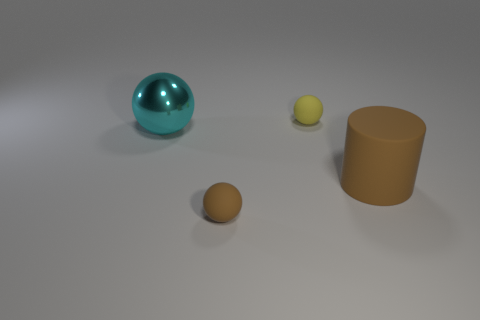Add 4 brown rubber cylinders. How many objects exist? 8 Subtract all large cyan spheres. How many spheres are left? 2 Subtract 1 cylinders. How many cylinders are left? 0 Subtract all cyan spheres. How many spheres are left? 2 Subtract all cylinders. How many objects are left? 3 Add 1 balls. How many balls are left? 4 Add 2 tiny matte things. How many tiny matte things exist? 4 Subtract 0 green balls. How many objects are left? 4 Subtract all gray cylinders. Subtract all gray spheres. How many cylinders are left? 1 Subtract all purple blocks. How many yellow spheres are left? 1 